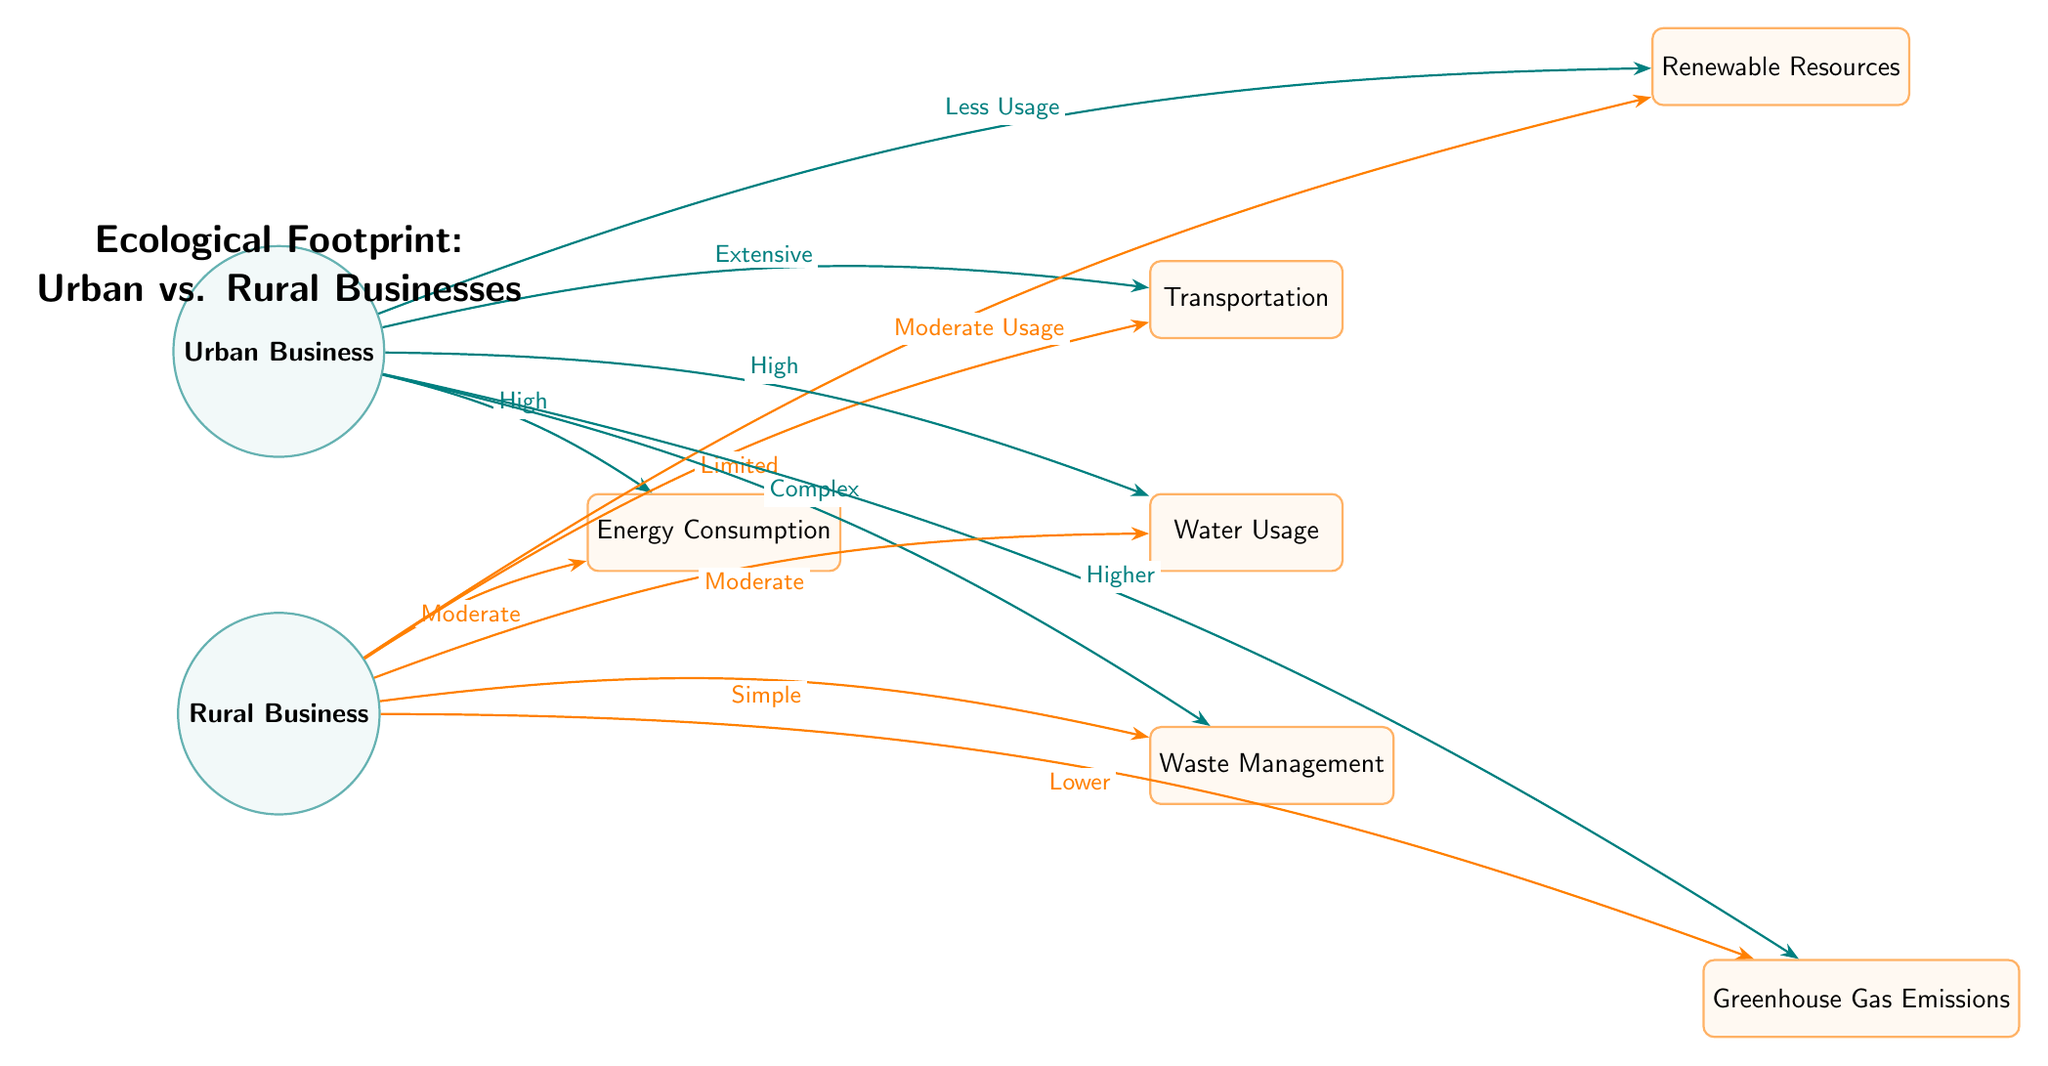What type of businesses does the diagram compare? The diagram compares Urban Businesses and Rural Businesses, as indicated by the main nodes at the top and bottom of the visual.
Answer: Urban and Rural Businesses What is the relationship between Urban Businesses and Energy Consumption? The arrow pointing from Urban Business to Energy Consumption is labeled 'High,' indicating a strong relationship where Urban Businesses have high energy consumption levels.
Answer: High How many factors are illustrated in the diagram? The diagram depicts a total of six factors, which are represented by rectangular nodes connected to the main nodes.
Answer: Six What is the level of Greenhouse Gas Emissions for Rural Businesses? The arrow from Rural Business to Greenhouse Gas Emissions has the label 'Lower,' indicating that Rural Businesses have lower emissions compared to Urban Businesses.
Answer: Lower How do Urban Businesses utilize Renewable Resources compared to Rural Businesses? The arrow from Urban Business to Renewable Resources indicates 'Less Usage,' whereas the Rural Business to Renewable Resources shows 'Moderate Usage,' suggesting that Urban Businesses use fewer renewable resources than Rural ones.
Answer: Less Usage vs. Moderate Usage What is the relationship between Transportation and Rural Businesses? The arrow pointing from Rural Business to Transportation is labeled 'Limited,' indicating that Rural Businesses have a limited transportation requirement compared to their urban counterparts.
Answer: Limited Which factor shows a complex relationship indicated for Urban Businesses? The Waste Management factor is marked as 'Complex' for Urban Businesses, showing that their waste management systems are more intricately designed than for Rural Businesses.
Answer: Complex How does Water Usage differ between Urban and Rural Businesses? Urban Businesses are connected to Water Usage with 'High,' while Rural has 'Moderate,' reflecting that Urban Businesses have a higher demand for water resources compared to Rural Businesses.
Answer: High vs. Moderate What type of diagram is this depicting ecological factors? This is a Natural Science Diagram that visually represents the ecological footprint and environmental impacts of different business settings in urban and rural contexts.
Answer: Natural Science Diagram 